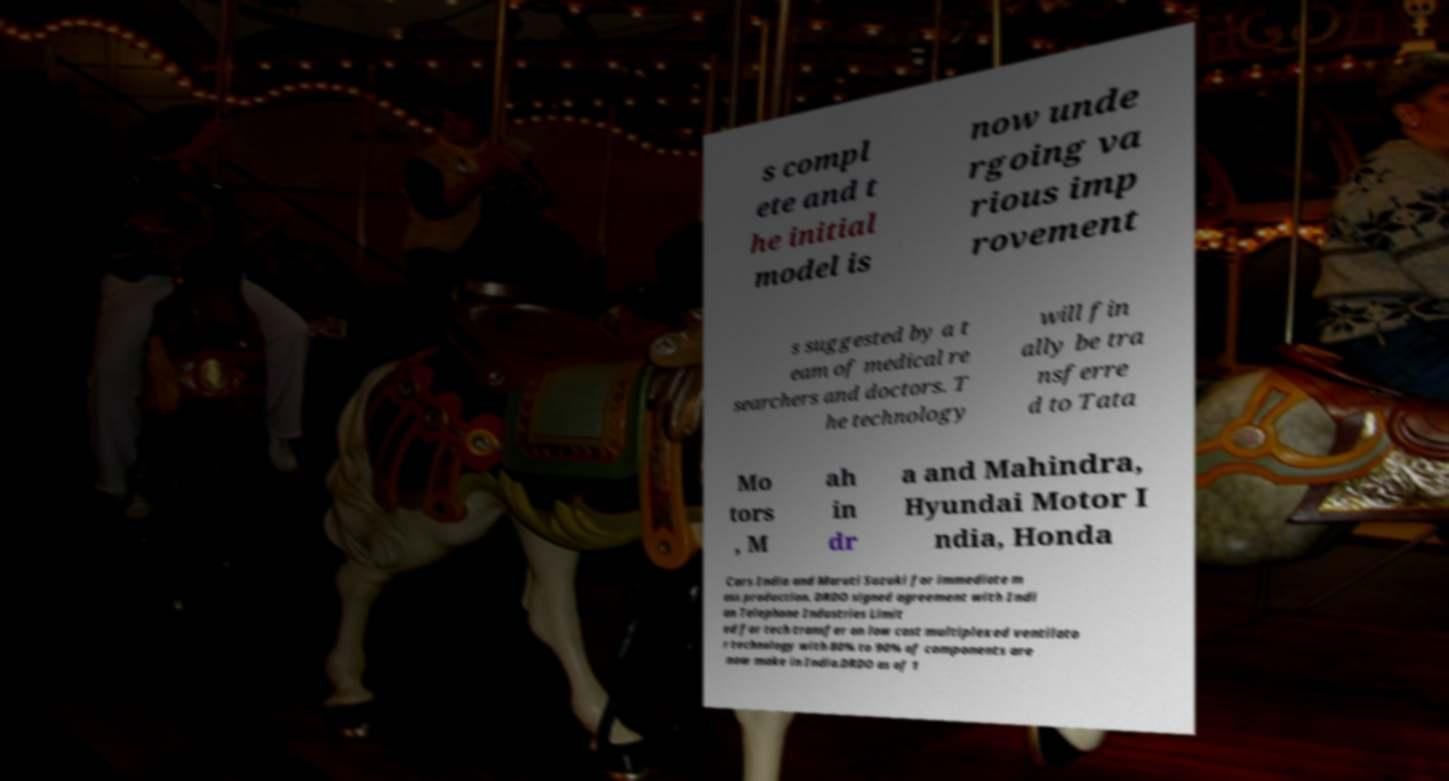Can you read and provide the text displayed in the image?This photo seems to have some interesting text. Can you extract and type it out for me? s compl ete and t he initial model is now unde rgoing va rious imp rovement s suggested by a t eam of medical re searchers and doctors. T he technology will fin ally be tra nsferre d to Tata Mo tors , M ah in dr a and Mahindra, Hyundai Motor I ndia, Honda Cars India and Maruti Suzuki for immediate m ass production. DRDO signed agreement with Indi an Telephone Industries Limit ed for tech transfer on low cost multiplexed ventilato r technology with 80% to 90% of components are now make in India.DRDO as of 1 